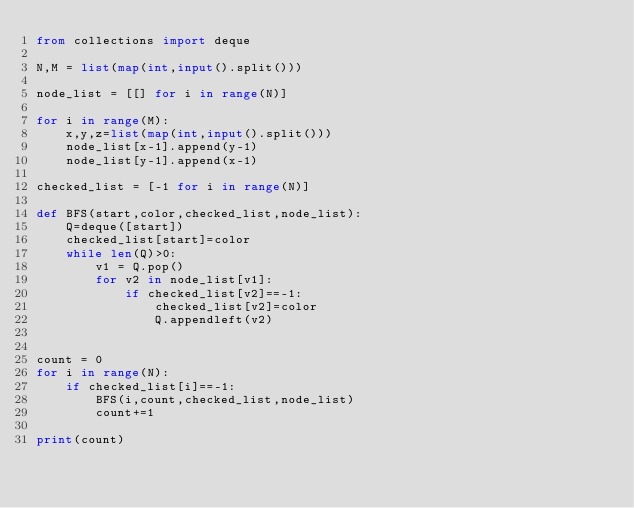Convert code to text. <code><loc_0><loc_0><loc_500><loc_500><_Python_>from collections import deque
    
N,M = list(map(int,input().split()))

node_list = [[] for i in range(N)]

for i in range(M):
    x,y,z=list(map(int,input().split()))
    node_list[x-1].append(y-1)
    node_list[y-1].append(x-1)

checked_list = [-1 for i in range(N)]

def BFS(start,color,checked_list,node_list):
    Q=deque([start])
    checked_list[start]=color
    while len(Q)>0:
        v1 = Q.pop()
        for v2 in node_list[v1]:
            if checked_list[v2]==-1:
                checked_list[v2]=color
                Q.appendleft(v2)


count = 0
for i in range(N):
    if checked_list[i]==-1:
        BFS(i,count,checked_list,node_list)
        count+=1
        
print(count)</code> 